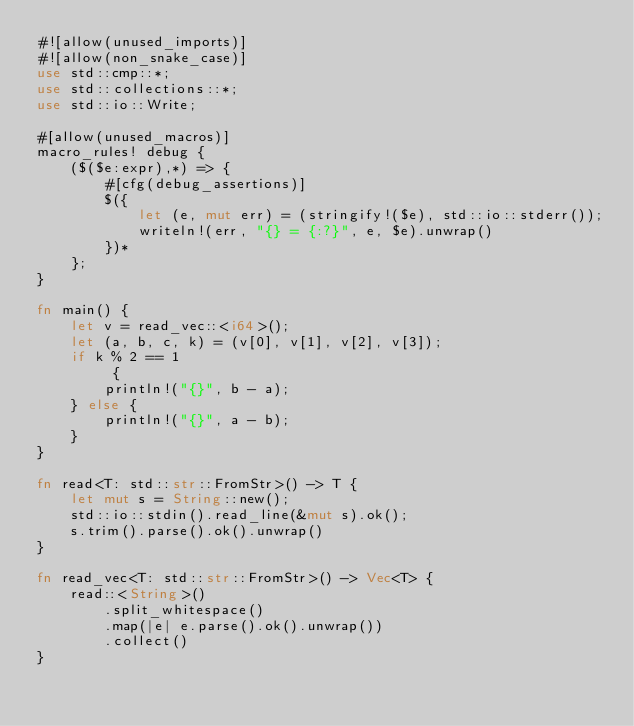<code> <loc_0><loc_0><loc_500><loc_500><_Rust_>#![allow(unused_imports)]
#![allow(non_snake_case)]
use std::cmp::*;
use std::collections::*;
use std::io::Write;

#[allow(unused_macros)]
macro_rules! debug {
    ($($e:expr),*) => {
        #[cfg(debug_assertions)]
        $({
            let (e, mut err) = (stringify!($e), std::io::stderr());
            writeln!(err, "{} = {:?}", e, $e).unwrap()
        })*
    };
}

fn main() {
    let v = read_vec::<i64>();
    let (a, b, c, k) = (v[0], v[1], v[2], v[3]);
    if k % 2 == 1
         {
        println!("{}", b - a);
    } else {
        println!("{}", a - b);
    }
}

fn read<T: std::str::FromStr>() -> T {
    let mut s = String::new();
    std::io::stdin().read_line(&mut s).ok();
    s.trim().parse().ok().unwrap()
}

fn read_vec<T: std::str::FromStr>() -> Vec<T> {
    read::<String>()
        .split_whitespace()
        .map(|e| e.parse().ok().unwrap())
        .collect()
}
</code> 